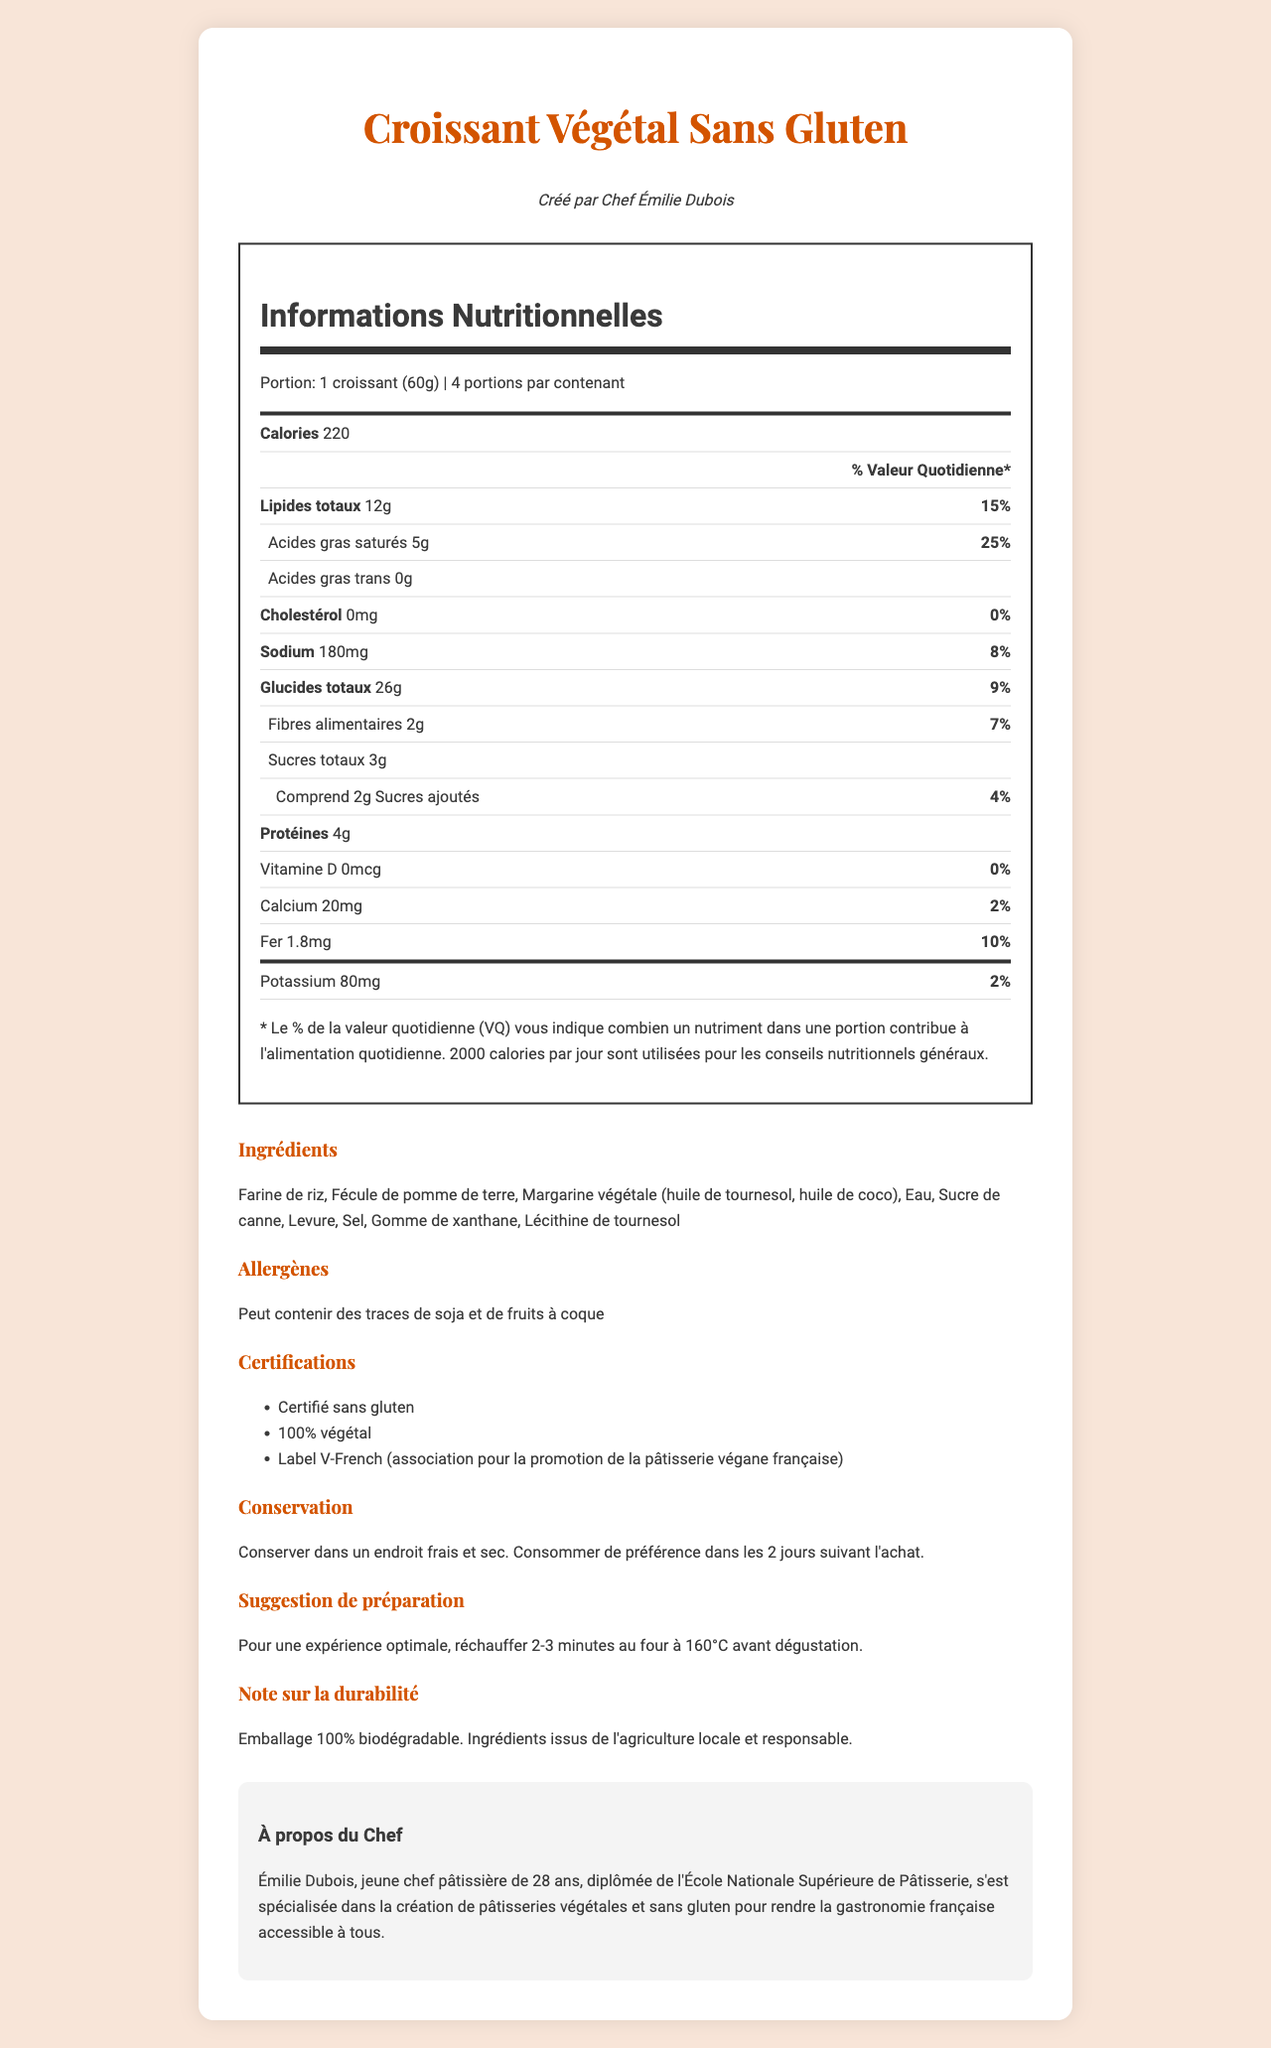what is the serving size for the Croissant Végétal Sans Gluten? The serving size is explicitly mentioned as "1 croissant (60g)" in the document.
Answer: 1 croissant (60g) how many servings are there per container? The document states that there are 4 servings per container.
Answer: 4 how many grams of total fat are in one serving? The document lists "total fat" as 12g per serving.
Answer: 12g what is the daily value percentage for saturated fat? The daily value percentage for saturated fat is provided as 25%.
Answer: 25% how much protein does one croissant contain? The document notes that one croissant contains 4g of protein.
Answer: 4g which ingredient is used as a binding agent? A. Lécithine de tournesol B. Fécule de pomme de terre C. Gomme de xanthane Gomme de xanthane is used as a binding agent, which is common in gluten-free products.
Answer: C what is the daily value percentage for iron in one serving? A. 2% B. 5% C. 10% D. 12% The daily value for iron is 10%, as stated in the nutrition facts.
Answer: C is the product certified gluten-free? The document lists "Certifié sans gluten" under certifications.
Answer: Yes are there any added sugars in the croissant? The document states that there are 2g of added sugars per serving.
Answer: Yes is Chef Émilie Dubois specialized in creating gluten-free pastries? The chef's background mentions that she specializes in creating gluten-free and vegan pastries.
Answer: Yes how should you store the croissant to maintain its quality? The storage instructions specify to keep it in a cool, dry place and consume it within 2 days of purchase.
Answer: Conserver dans un endroit frais et sec. Consommer de préférence dans les 2 jours suivant l'achat. how should you prepare the croissant for optimal taste? The preparation suggestion is to heat it for 2-3 minutes in an oven at 160°C.
Answer: Réchauffer 2-3 minutes au four à 160°C. what type of fatty acids are not present in the croissant? The document shows "Acides gras trans 0g", indicating that trans fats are not present.
Answer: Trans Fat what certifications does the croissant hold? The certifications listed are "Certifié sans gluten," "100% végétal," and "Label V-French."
Answer: Certifié sans gluten, 100% végétal, Label V-French (association pour la promotion de la pâtisserie végane française) summarize the main idea of the document. This detailed description covers the main elements of the document, focusing on the product's health aspects and the chef's background.
Answer: The document provides detailed nutritional information, ingredients, certifications, and storage and preparation instructions for the Croissant Végétal Sans Gluten, created by Chef Émilie Dubois, a specialist in gluten-free and vegan pastries. does the croissant contain Vitamin D? The nutrition facts show "Vitamine D 0mcg," indicating no Vitamin D content.
Answer: No which organization is associated with the promotion of vegan French pastries? The certification section mentions that Label V-French is associated with the promotion of vegan French pastries.
Answer: Label V-French how many calories are there in one serving? The calorie count per serving is listed as 220.
Answer: 220 what is the daily value percentage for the total carbohydrate content? The document states that the daily value percentage for total carbohydrates is 9%.
Answer: 9% what is the expiration period for the croissant? The document does not explicitly provide an expiration period, only that it should be consumed within 2 days of purchase. This is storage advice, not a definitive expiration date.
Answer: Not enough information 